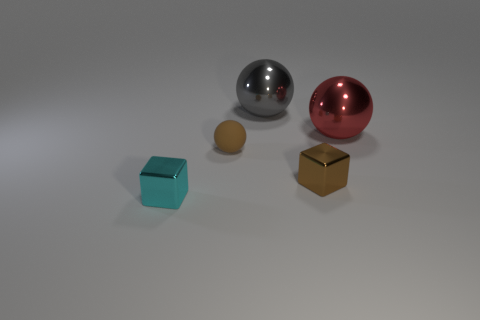Subtract 1 balls. How many balls are left? 2 Add 5 big red balls. How many objects exist? 10 Subtract all spheres. How many objects are left? 2 Subtract all small brown objects. Subtract all small cyan objects. How many objects are left? 2 Add 3 large red objects. How many large red objects are left? 4 Add 3 large yellow blocks. How many large yellow blocks exist? 3 Subtract 0 blue cubes. How many objects are left? 5 